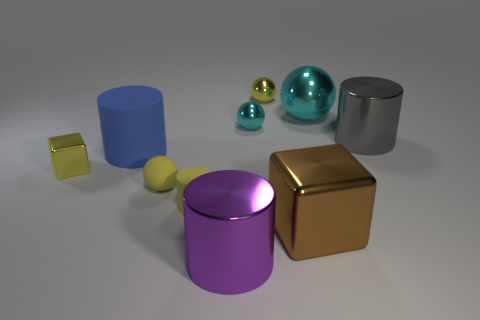Is there a tiny thing that has the same material as the tiny cube? Yes, there is a tiny sphere with a reflective surface that appears to have the same material as the tiny cube. 